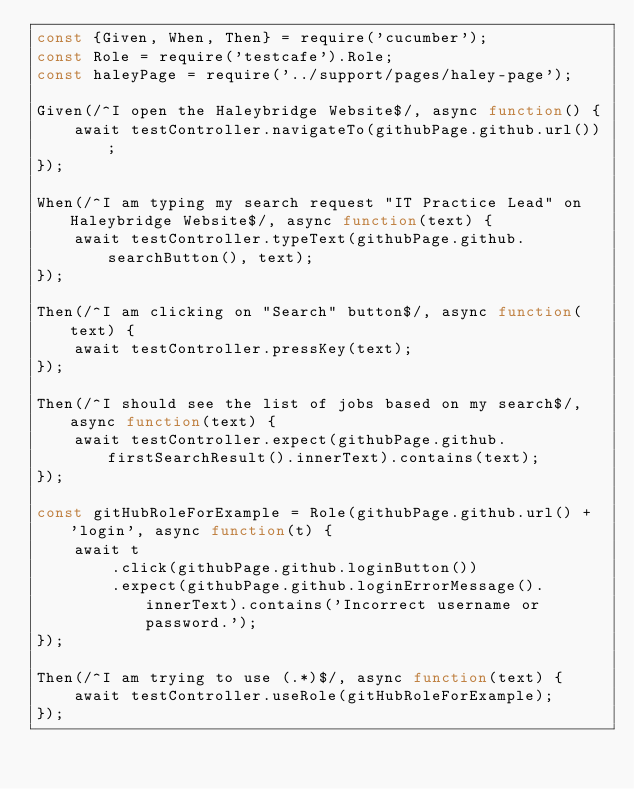<code> <loc_0><loc_0><loc_500><loc_500><_JavaScript_>const {Given, When, Then} = require('cucumber');
const Role = require('testcafe').Role;
const haleyPage = require('../support/pages/haley-page');

Given(/^I open the Haleybridge Website$/, async function() {
    await testController.navigateTo(githubPage.github.url());
});

When(/^I am typing my search request "IT Practice Lead" on Haleybridge Website$/, async function(text) {
    await testController.typeText(githubPage.github.searchButton(), text);
});

Then(/^I am clicking on "Search" button$/, async function(text) {
    await testController.pressKey(text);
});

Then(/^I should see the list of jobs based on my search$/, async function(text) {
    await testController.expect(githubPage.github.firstSearchResult().innerText).contains(text);
});

const gitHubRoleForExample = Role(githubPage.github.url() + 'login', async function(t) {
    await t
        .click(githubPage.github.loginButton())
        .expect(githubPage.github.loginErrorMessage().innerText).contains('Incorrect username or password.');
});

Then(/^I am trying to use (.*)$/, async function(text) {
    await testController.useRole(gitHubRoleForExample);
});
</code> 